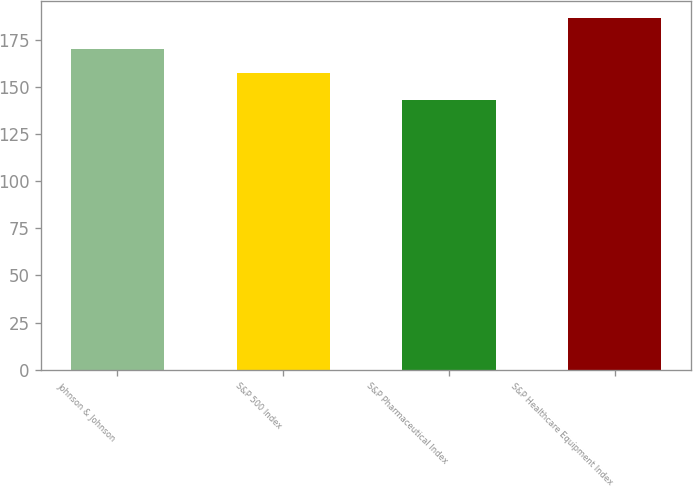Convert chart. <chart><loc_0><loc_0><loc_500><loc_500><bar_chart><fcel>Johnson & Johnson<fcel>S&P 500 Index<fcel>S&P Pharmaceutical Index<fcel>S&P Healthcare Equipment Index<nl><fcel>170.29<fcel>157.17<fcel>143.27<fcel>186.53<nl></chart> 